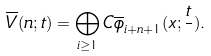Convert formula to latex. <formula><loc_0><loc_0><loc_500><loc_500>\overline { V } ( n ; t ) = \bigoplus _ { i \geq 1 } C \overline { \phi } _ { i + n + 1 } ( x ; \frac { t } { } ) .</formula> 